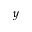<formula> <loc_0><loc_0><loc_500><loc_500>y</formula> 